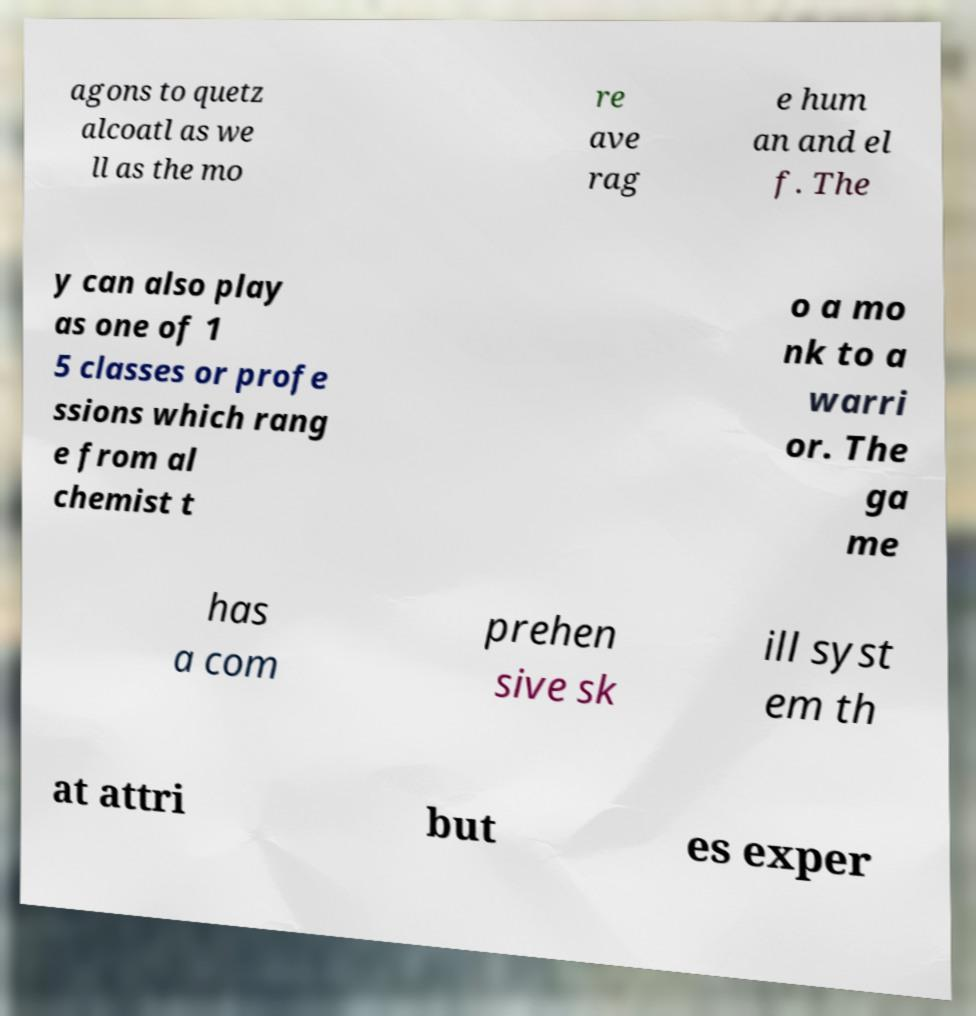For documentation purposes, I need the text within this image transcribed. Could you provide that? agons to quetz alcoatl as we ll as the mo re ave rag e hum an and el f. The y can also play as one of 1 5 classes or profe ssions which rang e from al chemist t o a mo nk to a warri or. The ga me has a com prehen sive sk ill syst em th at attri but es exper 